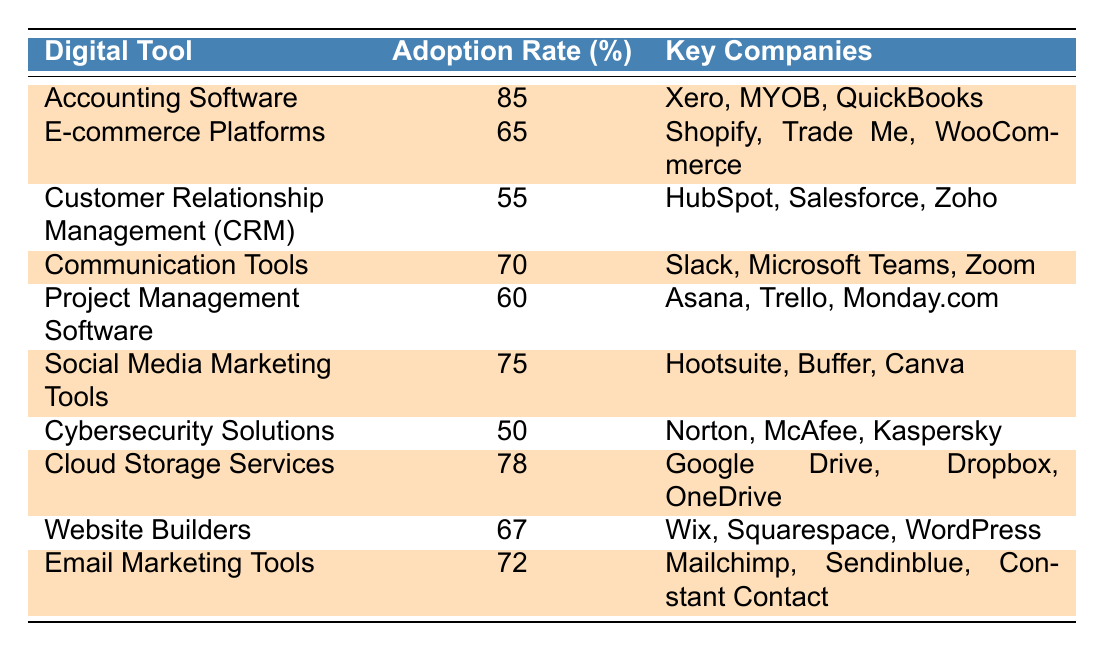What is the adoption rate of Accounting Software? The table shows that Accounting Software has an adoption rate of 85%.
Answer: 85% Which digital tool has the lowest adoption rate? By examining the adoption rates in the table, Cybersecurity Solutions has the lowest adoption rate at 50%.
Answer: 50% What are the key companies associated with E-commerce Platforms? The table lists Shopify, Trade Me, and WooCommerce as the key companies for E-commerce Platforms.
Answer: Shopify, Trade Me, WooCommerce Is the adoption rate for Cloud Storage Services higher than that of Communication Tools? Cloud Storage Services has an adoption rate of 78%, while Communication Tools has an adoption rate of 70%. Since 78% is greater than 70%, the answer is yes.
Answer: Yes What is the average adoption rate of the highlighted digital tools? The highlighted tools are Accounting Software (85%), E-commerce Platforms (65%), Communication Tools (70%), Social Media Marketing Tools (75%), Cloud Storage Services (78%), and Email Marketing Tools (72%). The sum is 85 + 65 + 70 + 75 + 78 + 72 = 445. There are 6 highlighted tools, so the average is 445/6 = 74.17.
Answer: 74.17 What percentage of small businesses adopted both Social Media Marketing Tools and Email Marketing Tools? The table shows that Social Media Marketing Tools has an adoption rate of 75% and Email Marketing Tools has an adoption rate of 72%. To find out the percentage adopted both, we'd look at their individual rates, but without overlap data, we cannot determine this. Therefore, the information is not available in the table.
Answer: Not available Which digital tools have an adoption rate above 70%? According to the table, the digital tools with adoption rates above 70% are Accounting Software (85%), Communication Tools (70%), Social Media Marketing Tools (75%), Cloud Storage Services (78%), and Email Marketing Tools (72%).
Answer: Accounting Software, Social Media Marketing Tools, Cloud Storage Services, Email Marketing Tools What is the difference in adoption rates between Cloud Storage Services and Cybersecurity Solutions? Cloud Storage Services has an adoption rate of 78%, while Cybersecurity Solutions has an adoption rate of 50%. The difference is 78 - 50 = 28.
Answer: 28 